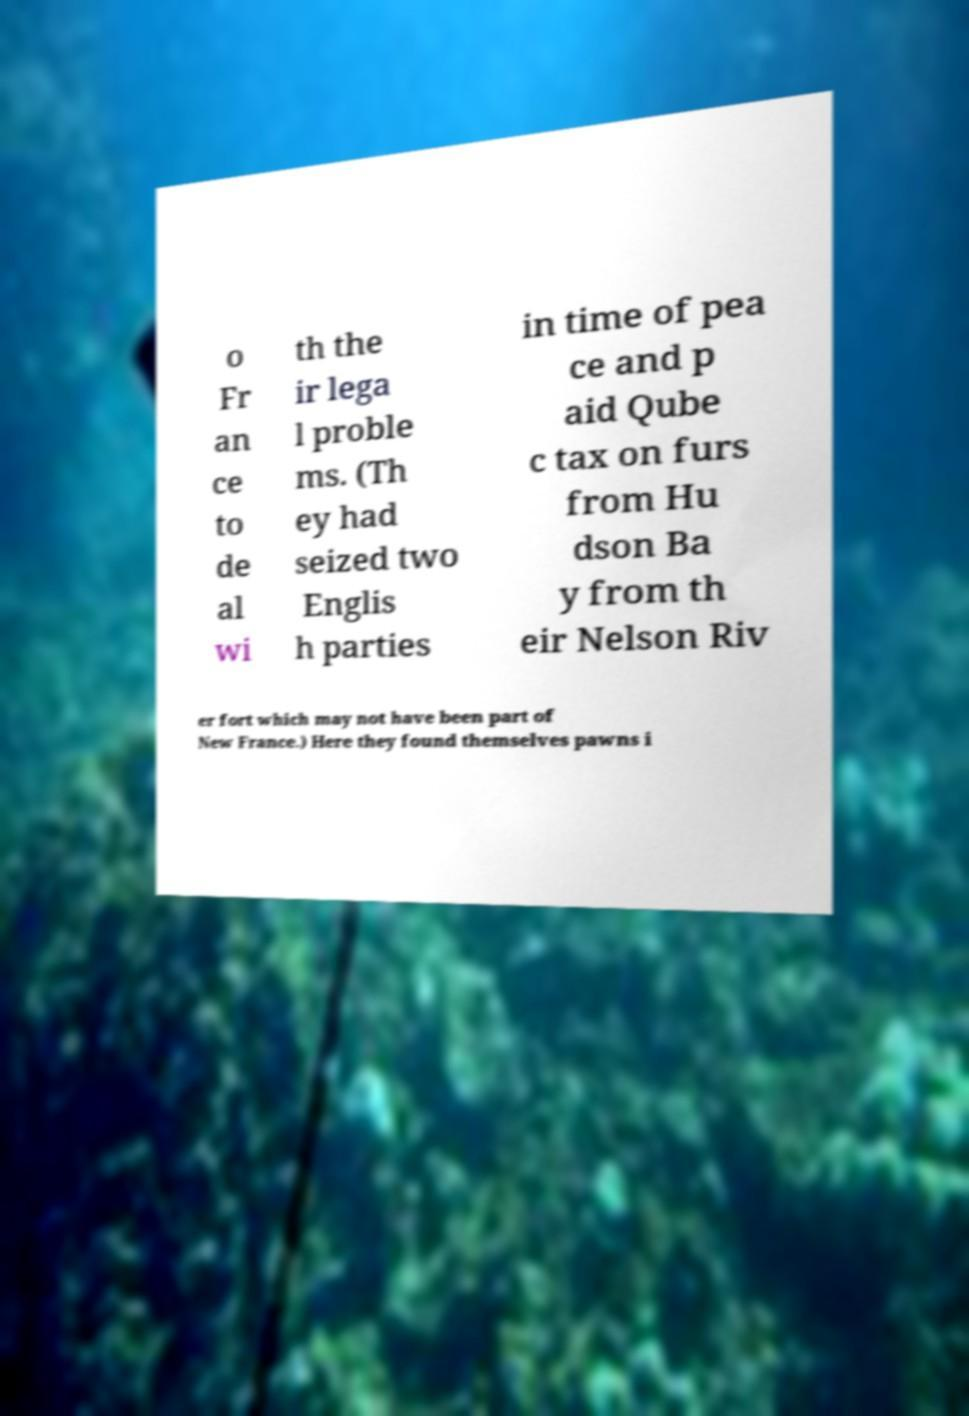Can you read and provide the text displayed in the image?This photo seems to have some interesting text. Can you extract and type it out for me? o Fr an ce to de al wi th the ir lega l proble ms. (Th ey had seized two Englis h parties in time of pea ce and p aid Qube c tax on furs from Hu dson Ba y from th eir Nelson Riv er fort which may not have been part of New France.) Here they found themselves pawns i 